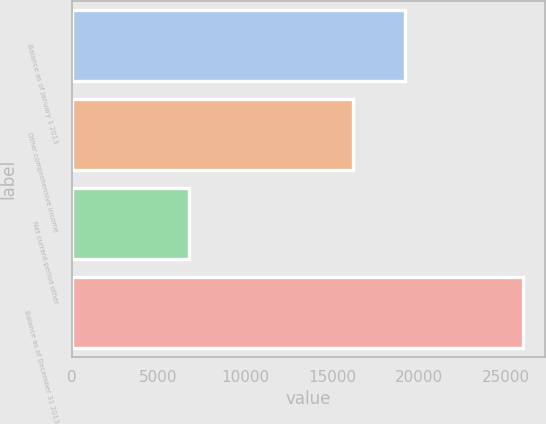<chart> <loc_0><loc_0><loc_500><loc_500><bar_chart><fcel>Balance as of January 1 2013<fcel>Other comprehensive income<fcel>Net current-period other<fcel>Balance as of December 31 2013<nl><fcel>19222<fcel>16205<fcel>6773<fcel>25995<nl></chart> 